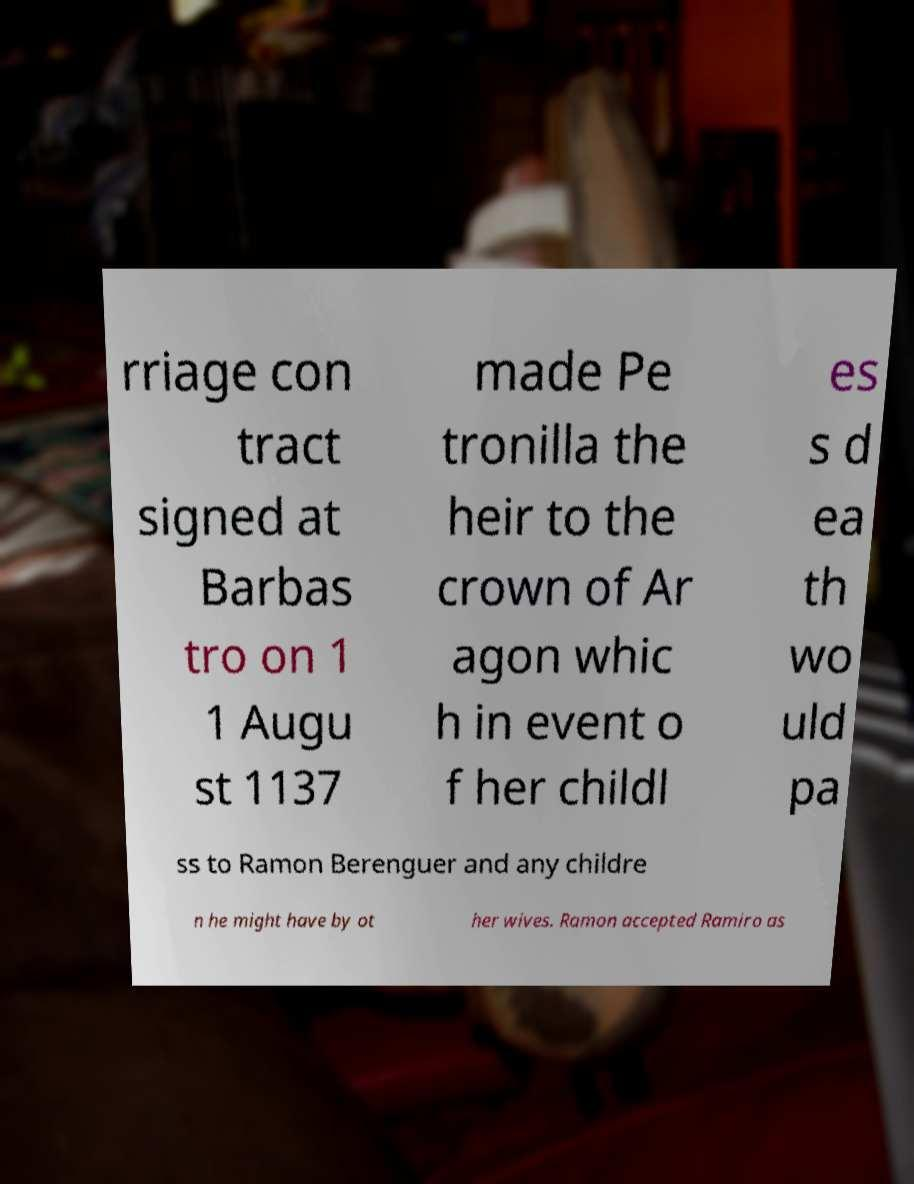Can you accurately transcribe the text from the provided image for me? rriage con tract signed at Barbas tro on 1 1 Augu st 1137 made Pe tronilla the heir to the crown of Ar agon whic h in event o f her childl es s d ea th wo uld pa ss to Ramon Berenguer and any childre n he might have by ot her wives. Ramon accepted Ramiro as 